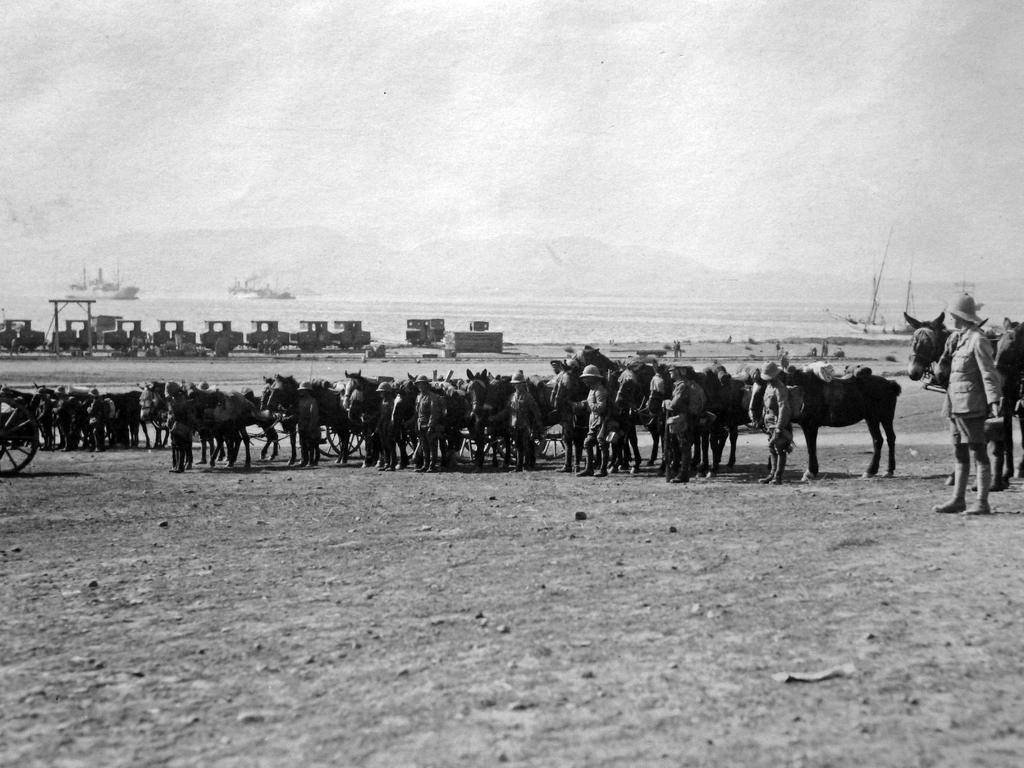Describe this image in one or two sentences. In this picture I can see there are a few people standing, they are few horses and there are soil and stones on the floor, in the backdrop, I can see there is an ocean, ships sailing on the water and there are few mountains and the sky is clear. 